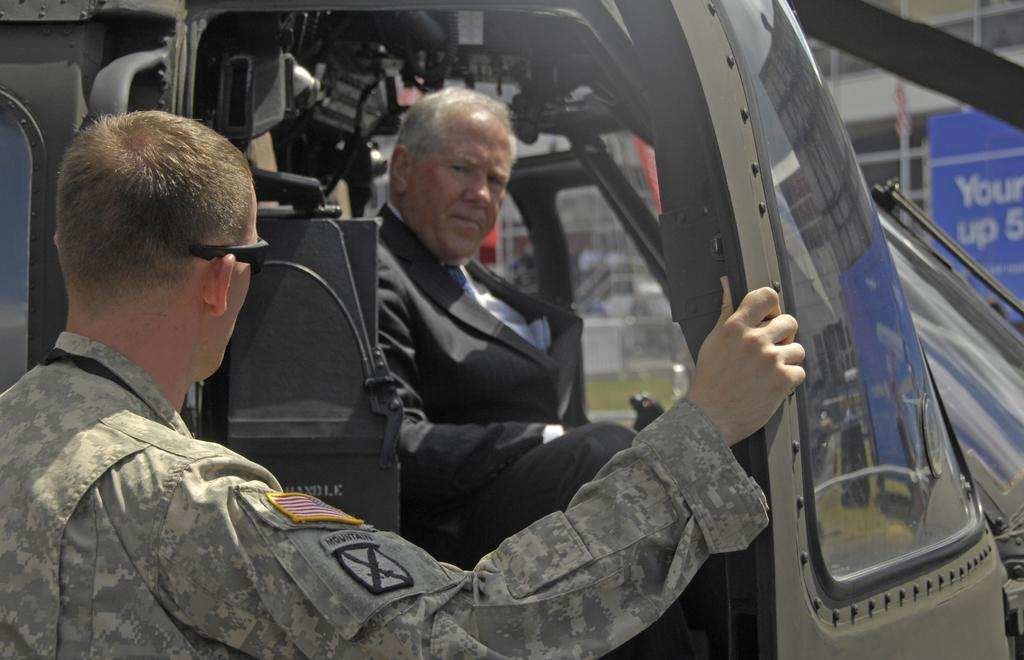How many people are present in the image? There are two people in the image. What else can be seen in the image besides the people? There are vehicles, a building, a poster, a fence, and some objects in the background of the image. What type of tin can be seen in the image? There is no tin present in the image. Can you tell me how many bushes are in the image? There is no mention of bushes in the provided facts, so it cannot be determined from the image. 